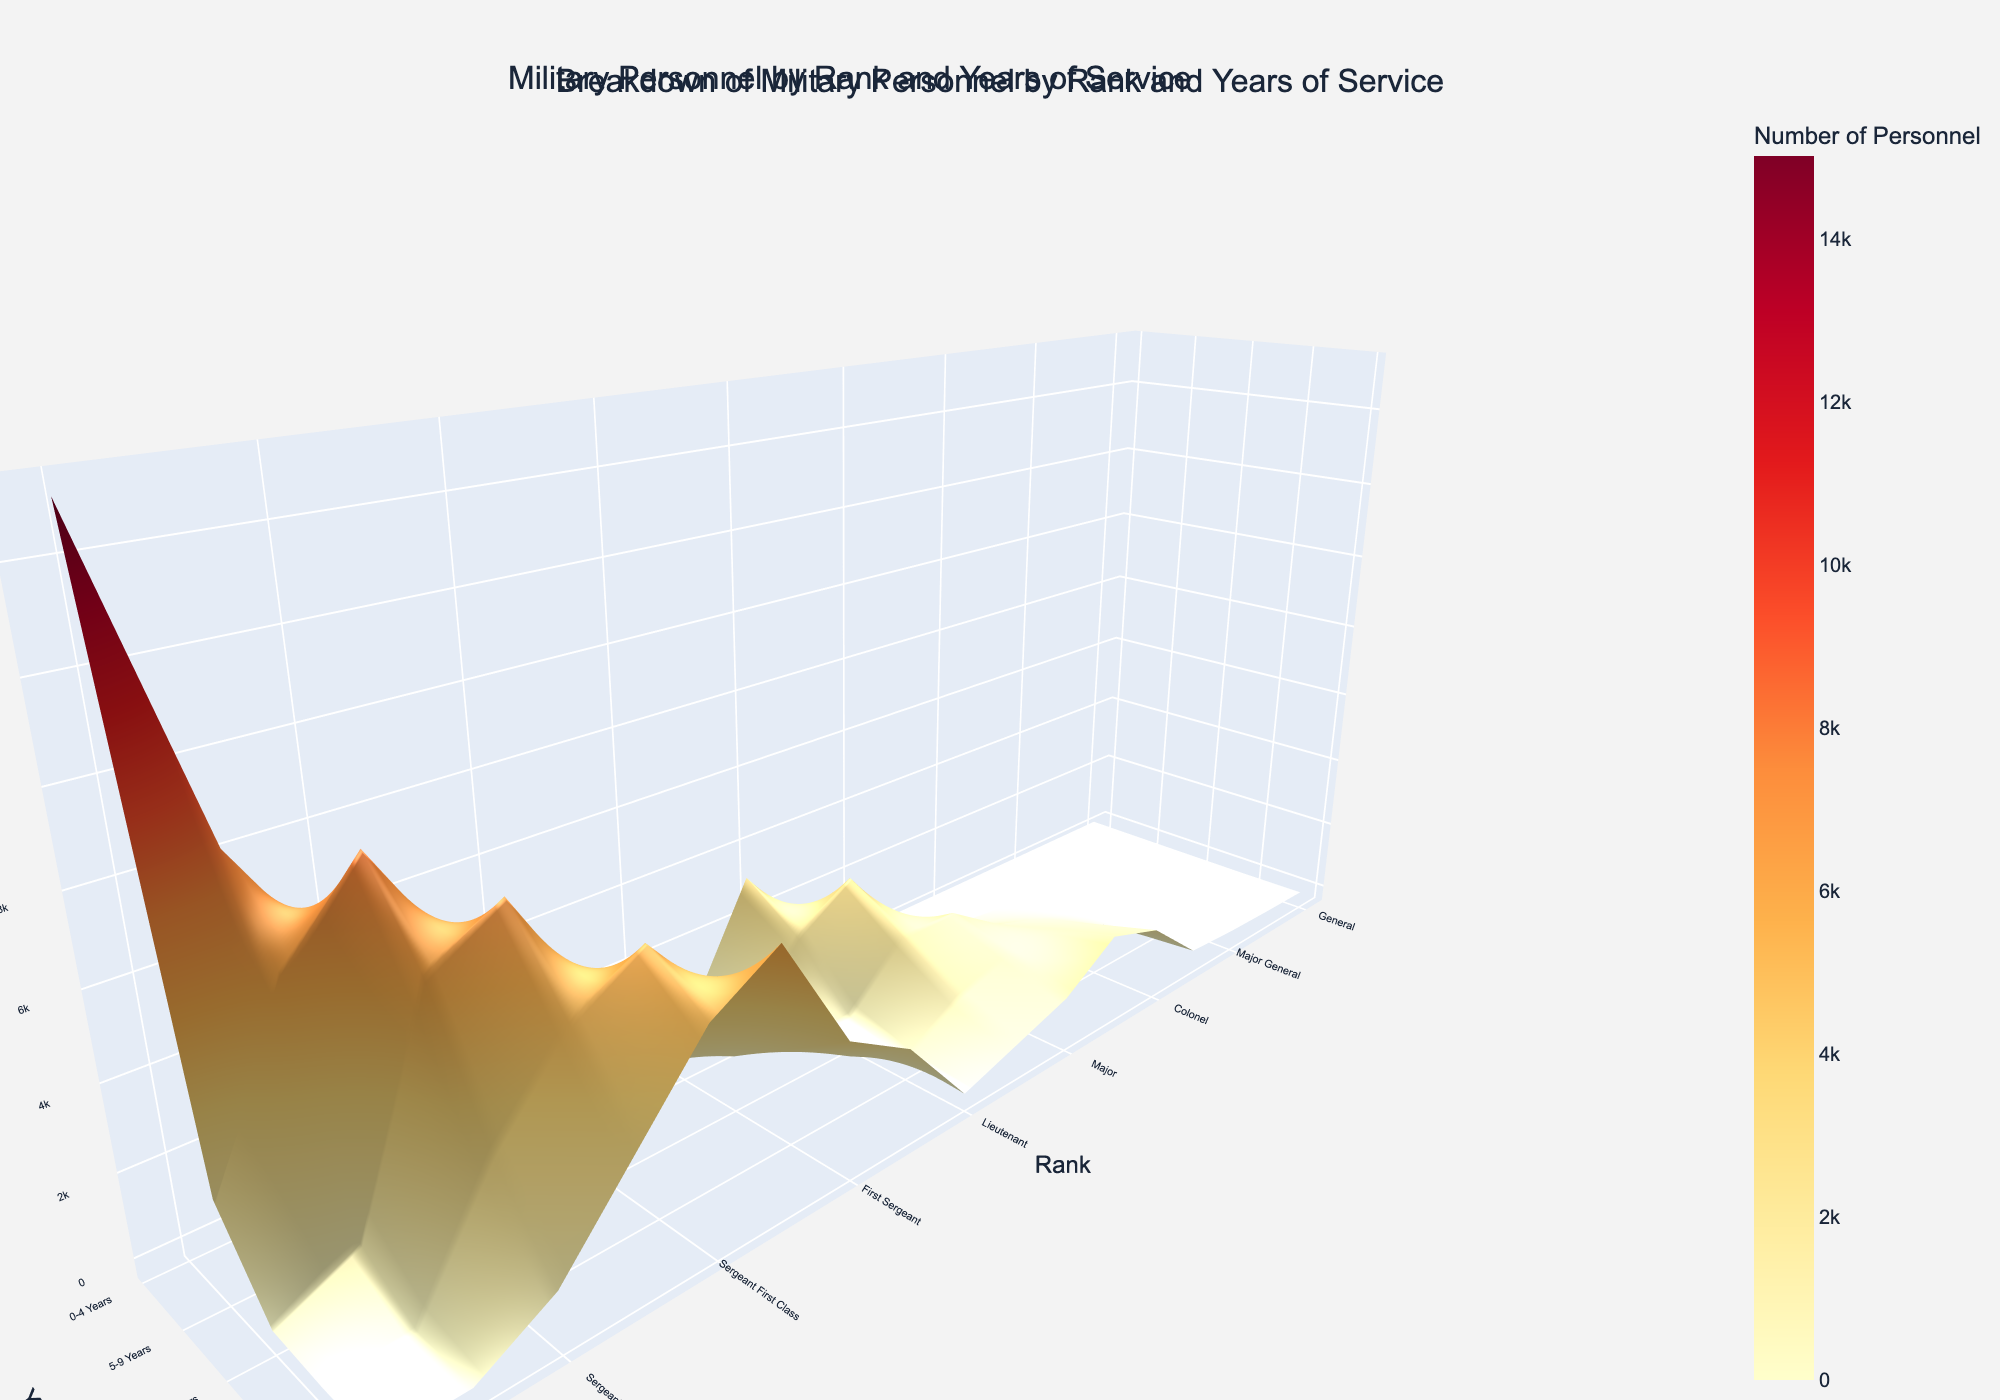What's the rank with the highest number of personnel for 0-4 years of service? To find the rank with the highest number of personnel for 0-4 years of service, look at the first column (0-4 Years) and identify the max value. Here, Private has the highest count with 15,000 personnel.
Answer: Private Which rank has personnel who served for 20+ years? Review the column for "20+ Years" and identify any non-zero entries. The ranks with personnel in the 20+ years of service are Sergeant, Staff Sergeant, Sergeant First Class, Master Sergeant, First Sergeant, Sergeant Major, Captain, Major, Lieutenant Colonel, Colonel, Brigadier General, Major General, Lieutenant General, and General.
Answer: Multiple Ranks Compare the number of personnel with 0-4 years of service for Private and Corporal, which has more? Look at the numbers in the 0-4 years column for Private (15,000) and Corporal (8,000). Compare the two values, and Private has more personnel.
Answer: Private What is the average number of personnel for the rank of Sergeant across all years of service? Add up the numbers for each year category under Sergeant: 5,000 (0-4) + 8,000 (5-9) + 6,000 (10-14) + 3,000 (15-19) + 1,000 (20+) = 23,000, then divide by the number of categories (5): 23,000 / 5 = 4,600.
Answer: 4,600 Which rank has the least personnel in the 15-19 years category? Check the "15-19 Years" column to find the smallest non-zero value. First Sergeant has the least with 2,000 personnel.
Answer: First Sergeant What is the total number of personnel in the category of Staff Sergeant? Sum the values for Staff Sergeant across all year categories: 2,000 (0-4) + 5,000 (5-9) + 7,000 (10-14) + 5,000 (15-19) + 3,000 (20+) = 22,000.
Answer: 22,000 How does the number of personnel for the rank of Major General with 10-14 years compare to those with 15-19 years? Look at the numbers for Major General: 10-14 years has 5, and 15-19 years has 20.  There are more personnel in the 15-19 years category.
Answer: 15-19 years Which category and rank combination has the highest number of personnel? Find the highest value in the entire dataset. The highest number of personnel is 15,000 for the rank of Private with 0-4 years of service.
Answer: Private, 0-4 years 